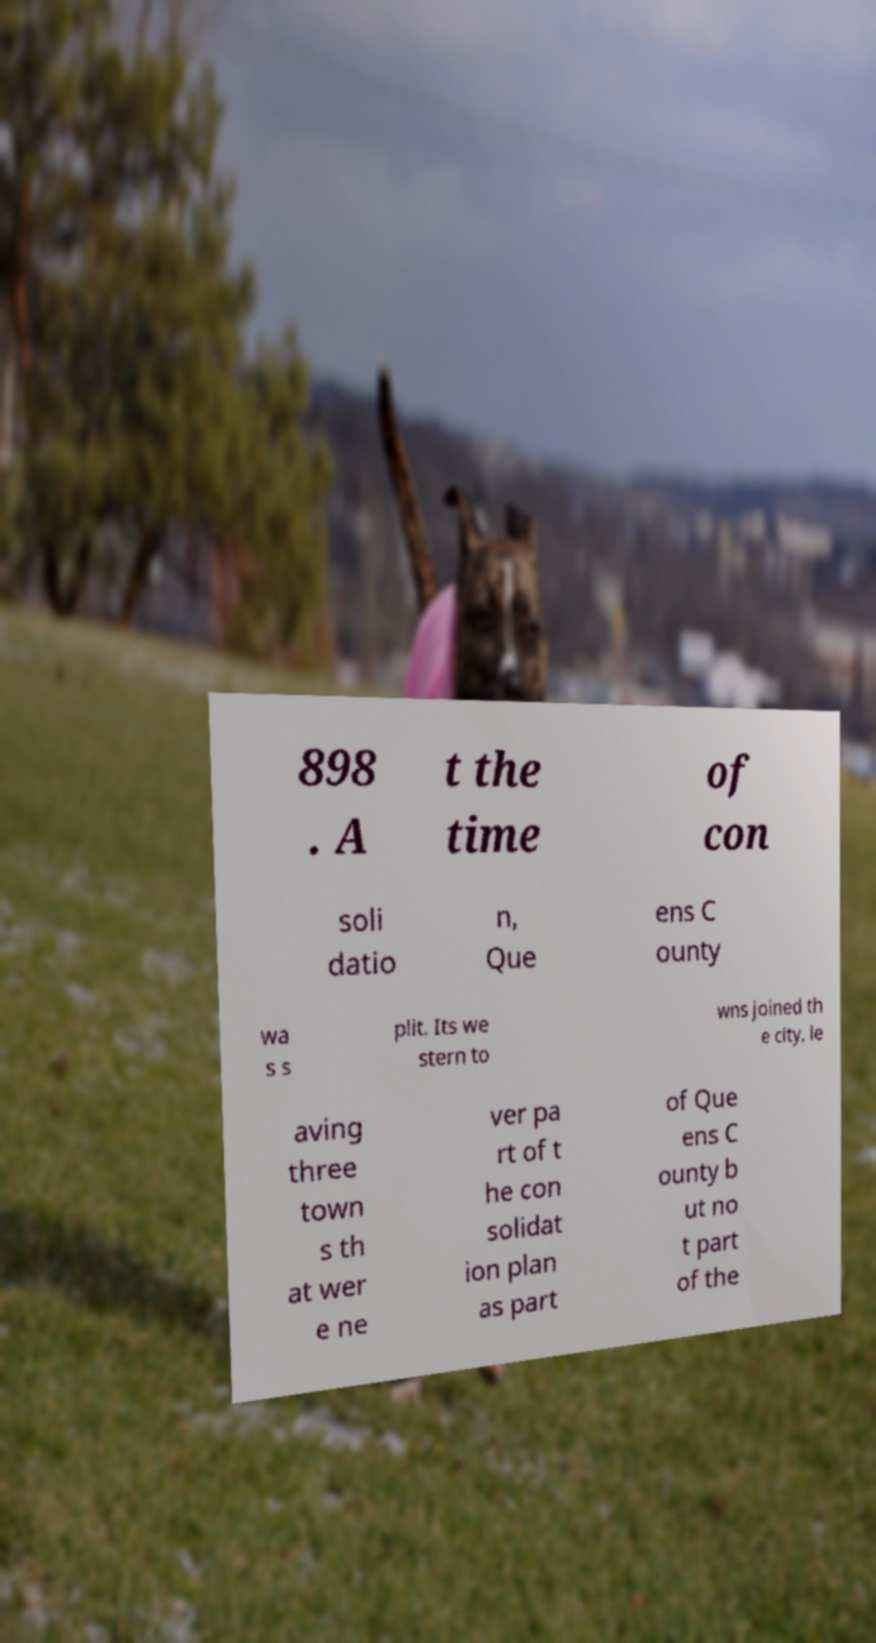Can you accurately transcribe the text from the provided image for me? 898 . A t the time of con soli datio n, Que ens C ounty wa s s plit. Its we stern to wns joined th e city, le aving three town s th at wer e ne ver pa rt of t he con solidat ion plan as part of Que ens C ounty b ut no t part of the 